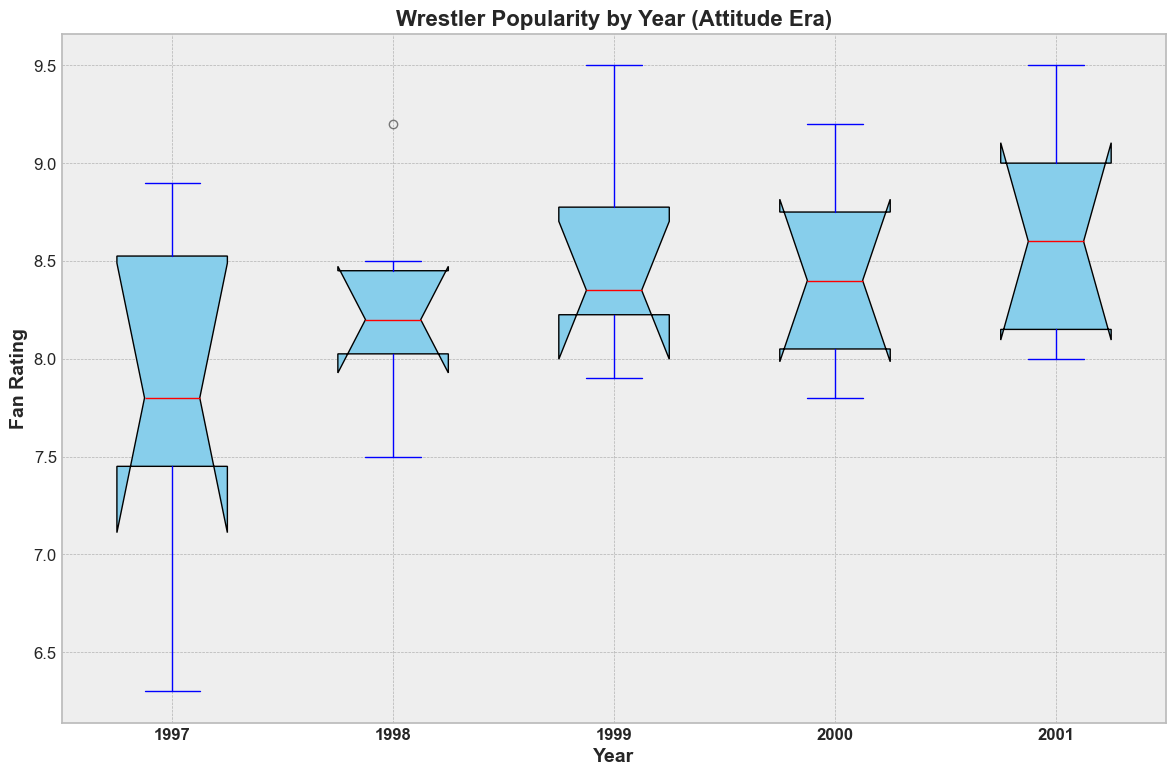How does the median fan rating of wrestlers in 1997 compare to 1999? To find the median fan rating, observe the central line inside each box for the years 1997 and 1999. The median in 1997 appears to be lower than that in 1999.
Answer: The median rating in 1997 is lower compared to 1999 Which year had the highest median fan rating for wrestlers? Observe the central line inside the boxes for each year and identify which one is the highest. The year 2001 appears to have the highest median fan rating.
Answer: 2001 has the highest median rating What do the red lines in each box represent? The red lines in each boxplot represent the median fan rating for wrestlers in that particular year.
Answer: The median fan rating Which year has the widest range of fan ratings? The range of fan ratings is determined by looking at the whiskers (lines extending from the boxes). Identify the year where the whiskers span the widest range. The year 1997 seems to have the widest spread of fan ratings.
Answer: 1997 How does the overall distribution of fan ratings change from 1997 to 2001? Notice the variability and central tendency changes in the box plots from 1997 to 2001. The ratings generally increase over the years, with the median ratings increasing and the interquartile ranges (spans of boxes) possibly changing.
Answer: The fan ratings generally increased In which year do you observe the smallest interquartile range (IQR) of fan ratings? The IQR is the range within the box (from the lower quartile to the upper quartile). Identify the year with the smallest box. The year 1997 seems to have the smallest IQR.
Answer: 1997 Are there any outliers in the data, and in which years do they appear? Outliers are marked by circles outside the whiskers. Look for any outliers in the figure. Outliers appear in 1997 and 1998.
Answer: 1997 and 1998 